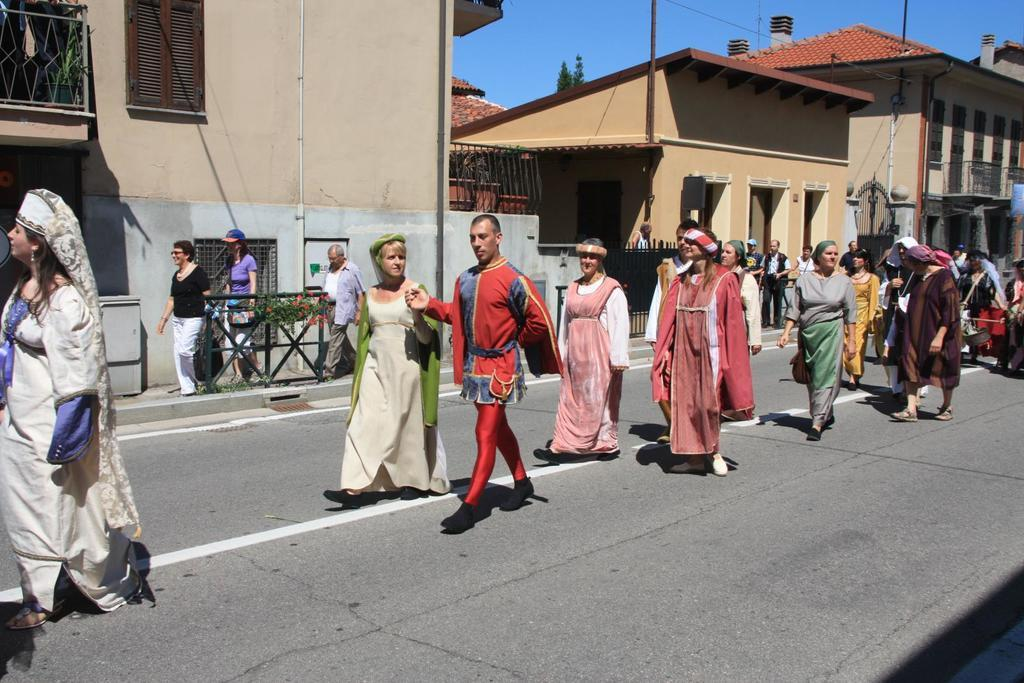What are the people in the image doing? The people in the image are walking on the road. What are the people wearing while walking? The people are wearing different costumes. What can be seen in the background of the image? There are buildings, a tree, fencing, and the sky visible in the background. What type of cup is being used to achieve a new world record in the image? There is no cup or world record attempt present in the image. 